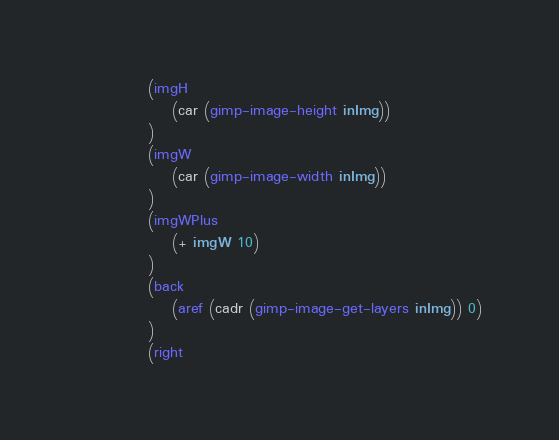Convert code to text. <code><loc_0><loc_0><loc_500><loc_500><_Scheme_>			(imgH
				(car (gimp-image-height inImg))
			)
			(imgW
				(car (gimp-image-width inImg))
			)
			(imgWPlus
				(+ imgW 10)
			)
			(back
				(aref (cadr (gimp-image-get-layers inImg)) 0)
			)
			(right</code> 